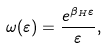Convert formula to latex. <formula><loc_0><loc_0><loc_500><loc_500>\omega ( \varepsilon ) = \frac { e ^ { \beta _ { H } \varepsilon } } { \varepsilon } ,</formula> 